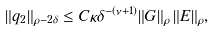<formula> <loc_0><loc_0><loc_500><loc_500>\| q _ { 2 } \| _ { \rho - 2 \delta } \leq C \kappa \delta ^ { - ( \nu + 1 ) } \| G \| _ { \rho } \, \| E \| _ { \rho } ,</formula> 